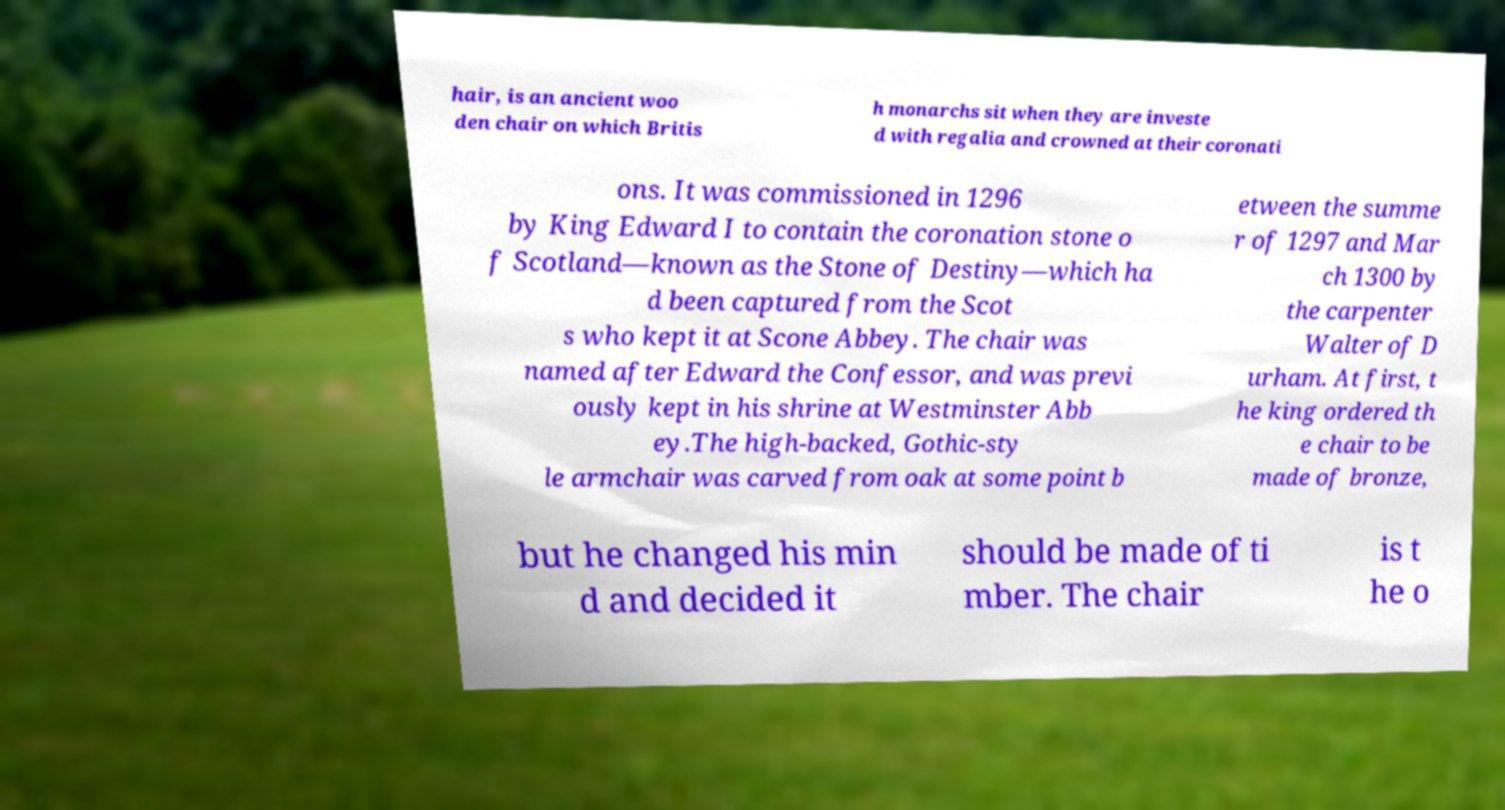What messages or text are displayed in this image? I need them in a readable, typed format. hair, is an ancient woo den chair on which Britis h monarchs sit when they are investe d with regalia and crowned at their coronati ons. It was commissioned in 1296 by King Edward I to contain the coronation stone o f Scotland—known as the Stone of Destiny—which ha d been captured from the Scot s who kept it at Scone Abbey. The chair was named after Edward the Confessor, and was previ ously kept in his shrine at Westminster Abb ey.The high-backed, Gothic-sty le armchair was carved from oak at some point b etween the summe r of 1297 and Mar ch 1300 by the carpenter Walter of D urham. At first, t he king ordered th e chair to be made of bronze, but he changed his min d and decided it should be made of ti mber. The chair is t he o 